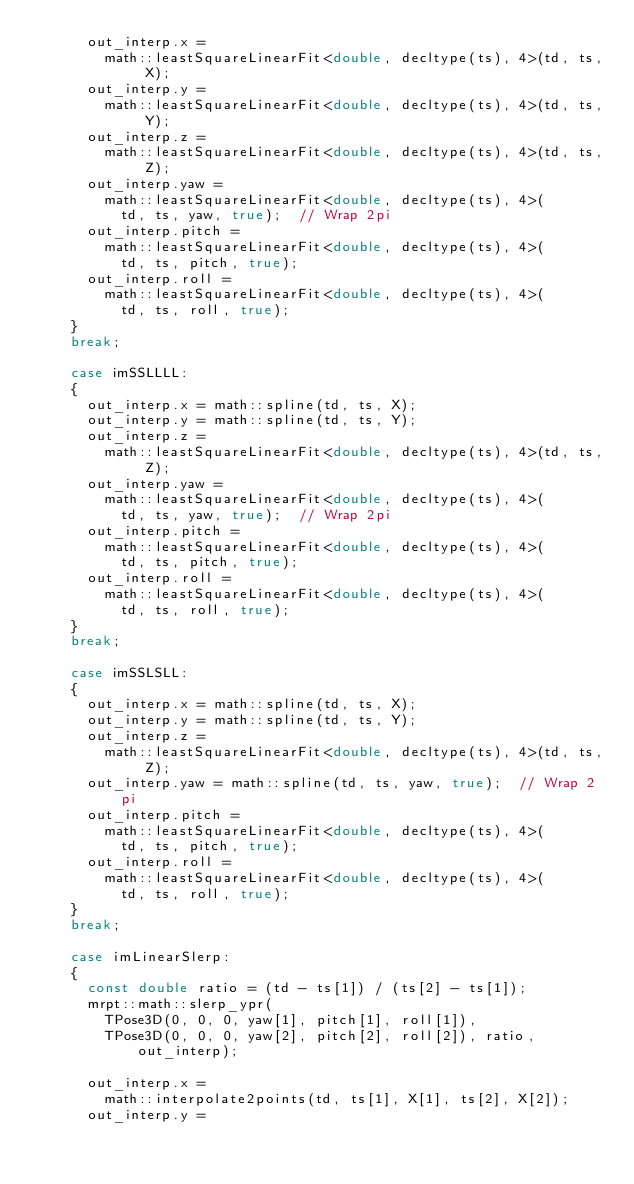Convert code to text. <code><loc_0><loc_0><loc_500><loc_500><_C++_>			out_interp.x =
				math::leastSquareLinearFit<double, decltype(ts), 4>(td, ts, X);
			out_interp.y =
				math::leastSquareLinearFit<double, decltype(ts), 4>(td, ts, Y);
			out_interp.z =
				math::leastSquareLinearFit<double, decltype(ts), 4>(td, ts, Z);
			out_interp.yaw =
				math::leastSquareLinearFit<double, decltype(ts), 4>(
					td, ts, yaw, true);	 // Wrap 2pi
			out_interp.pitch =
				math::leastSquareLinearFit<double, decltype(ts), 4>(
					td, ts, pitch, true);
			out_interp.roll =
				math::leastSquareLinearFit<double, decltype(ts), 4>(
					td, ts, roll, true);
		}
		break;

		case imSSLLLL:
		{
			out_interp.x = math::spline(td, ts, X);
			out_interp.y = math::spline(td, ts, Y);
			out_interp.z =
				math::leastSquareLinearFit<double, decltype(ts), 4>(td, ts, Z);
			out_interp.yaw =
				math::leastSquareLinearFit<double, decltype(ts), 4>(
					td, ts, yaw, true);	 // Wrap 2pi
			out_interp.pitch =
				math::leastSquareLinearFit<double, decltype(ts), 4>(
					td, ts, pitch, true);
			out_interp.roll =
				math::leastSquareLinearFit<double, decltype(ts), 4>(
					td, ts, roll, true);
		}
		break;

		case imSSLSLL:
		{
			out_interp.x = math::spline(td, ts, X);
			out_interp.y = math::spline(td, ts, Y);
			out_interp.z =
				math::leastSquareLinearFit<double, decltype(ts), 4>(td, ts, Z);
			out_interp.yaw = math::spline(td, ts, yaw, true);  // Wrap 2pi
			out_interp.pitch =
				math::leastSquareLinearFit<double, decltype(ts), 4>(
					td, ts, pitch, true);
			out_interp.roll =
				math::leastSquareLinearFit<double, decltype(ts), 4>(
					td, ts, roll, true);
		}
		break;

		case imLinearSlerp:
		{
			const double ratio = (td - ts[1]) / (ts[2] - ts[1]);
			mrpt::math::slerp_ypr(
				TPose3D(0, 0, 0, yaw[1], pitch[1], roll[1]),
				TPose3D(0, 0, 0, yaw[2], pitch[2], roll[2]), ratio, out_interp);

			out_interp.x =
				math::interpolate2points(td, ts[1], X[1], ts[2], X[2]);
			out_interp.y =</code> 